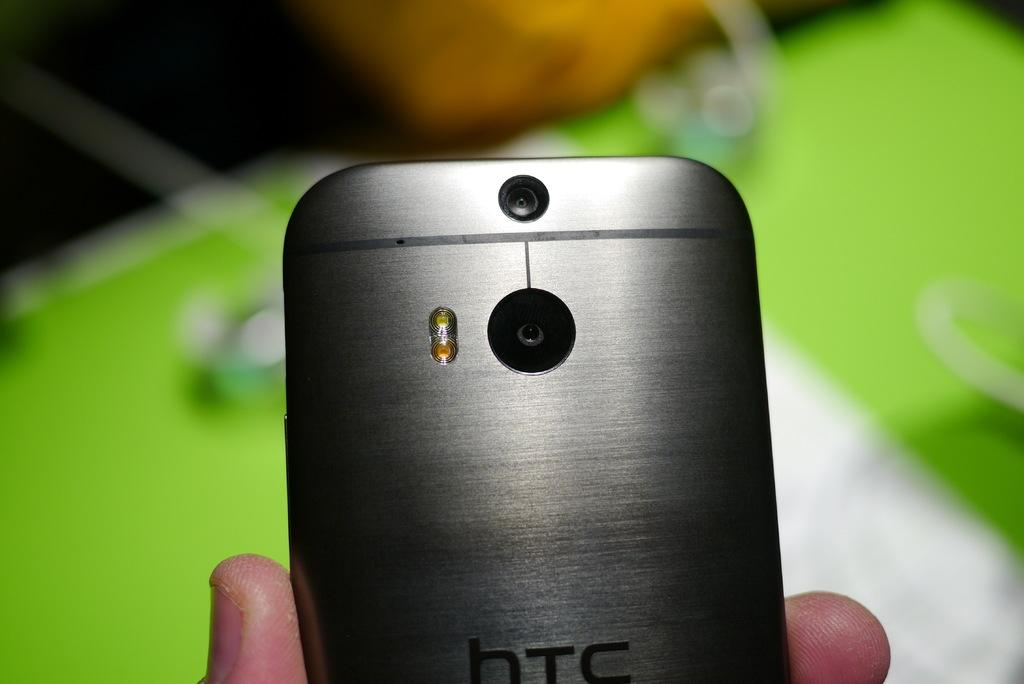<image>
Provide a brief description of the given image. HTC smartphone with camera in brushed silver color 